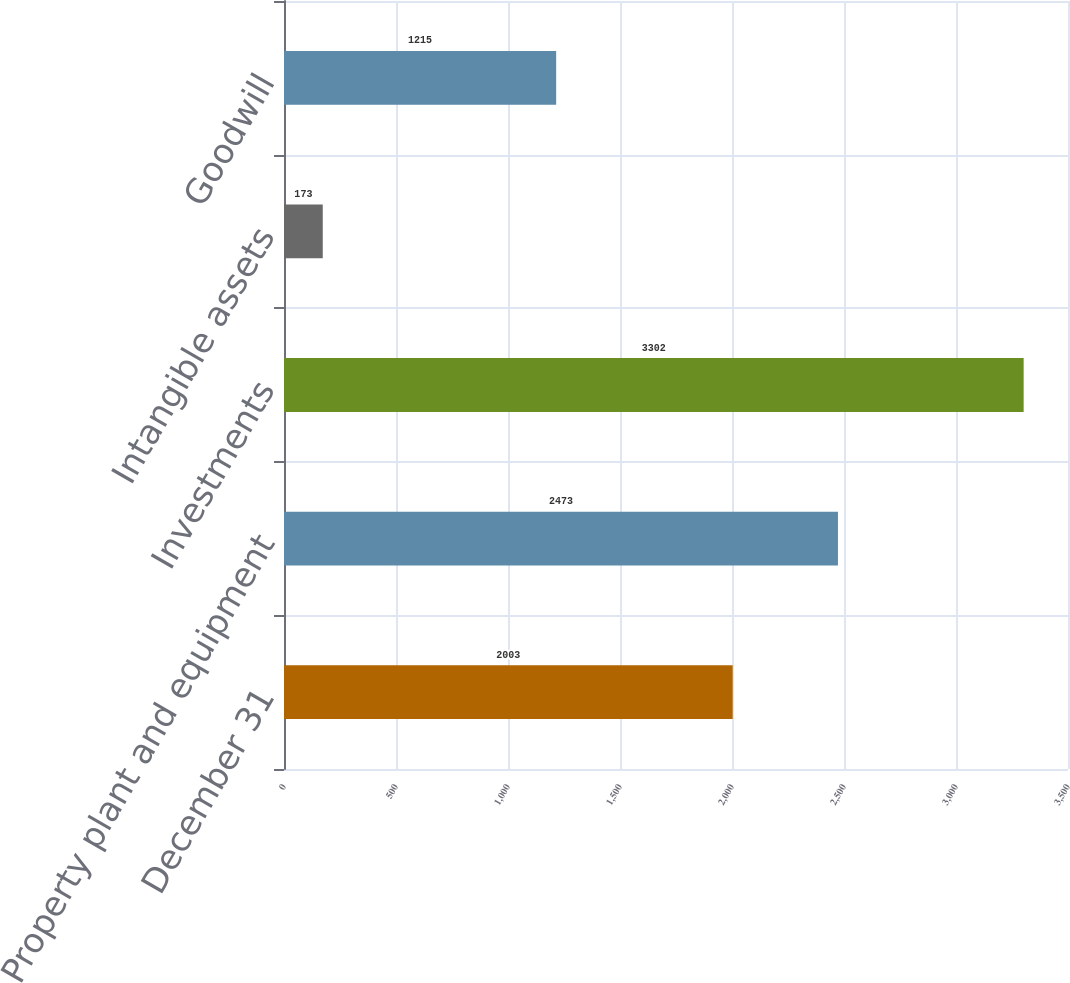Convert chart. <chart><loc_0><loc_0><loc_500><loc_500><bar_chart><fcel>December 31<fcel>Property plant and equipment<fcel>Investments<fcel>Intangible assets<fcel>Goodwill<nl><fcel>2003<fcel>2473<fcel>3302<fcel>173<fcel>1215<nl></chart> 